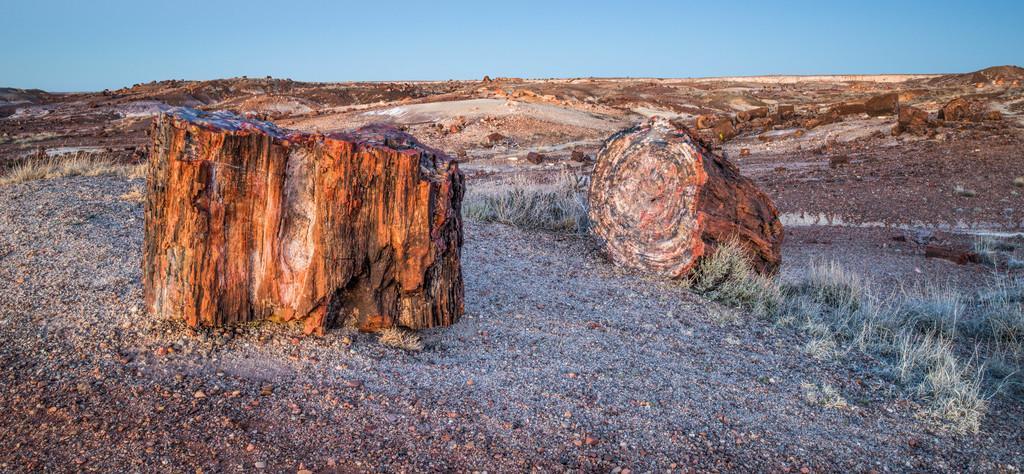Describe this image in one or two sentences. At the bottom of the picture, we see the sand and stones. In the middle of the picture, we see the wood. On the right side, we see the grass. There are stones and rocks in the background. At the top, we see the sky, which is blue in color. 